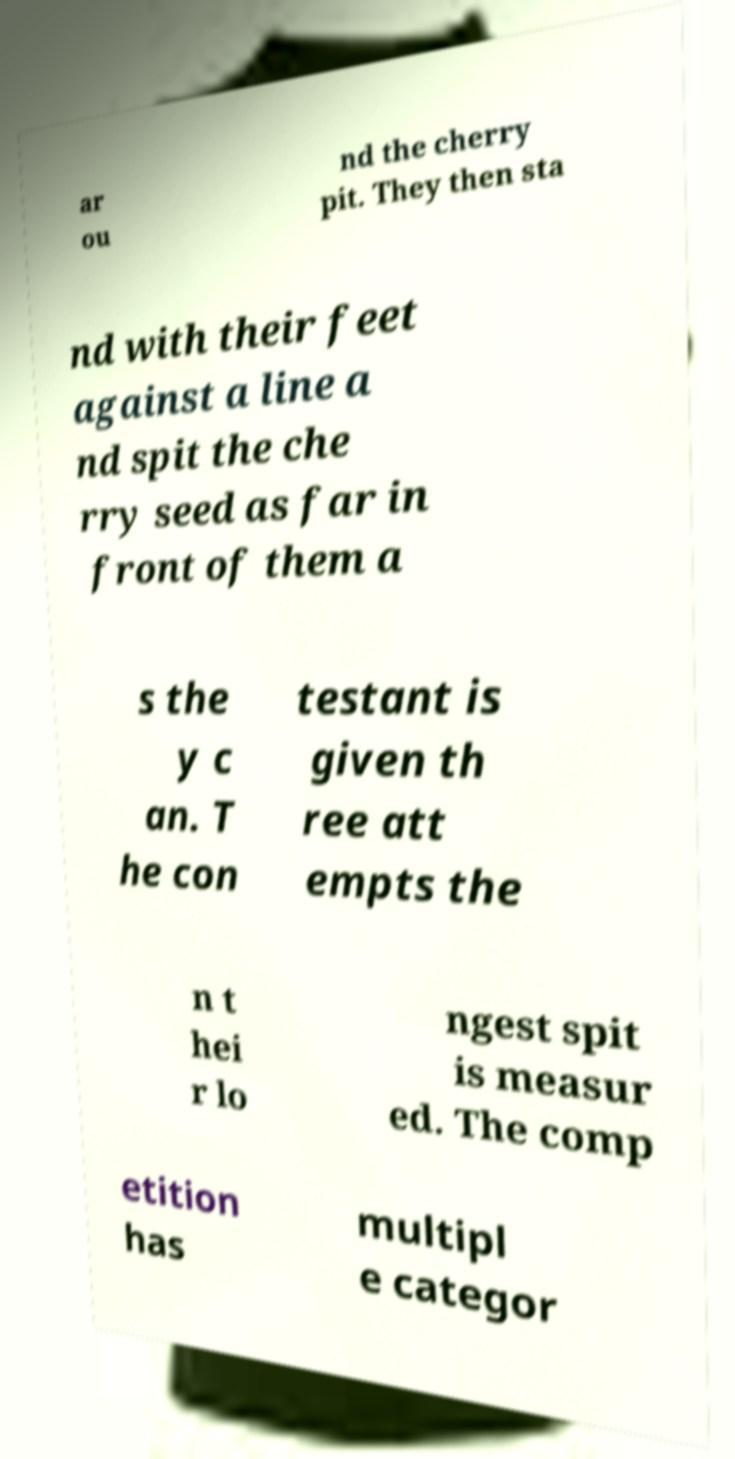I need the written content from this picture converted into text. Can you do that? ar ou nd the cherry pit. They then sta nd with their feet against a line a nd spit the che rry seed as far in front of them a s the y c an. T he con testant is given th ree att empts the n t hei r lo ngest spit is measur ed. The comp etition has multipl e categor 